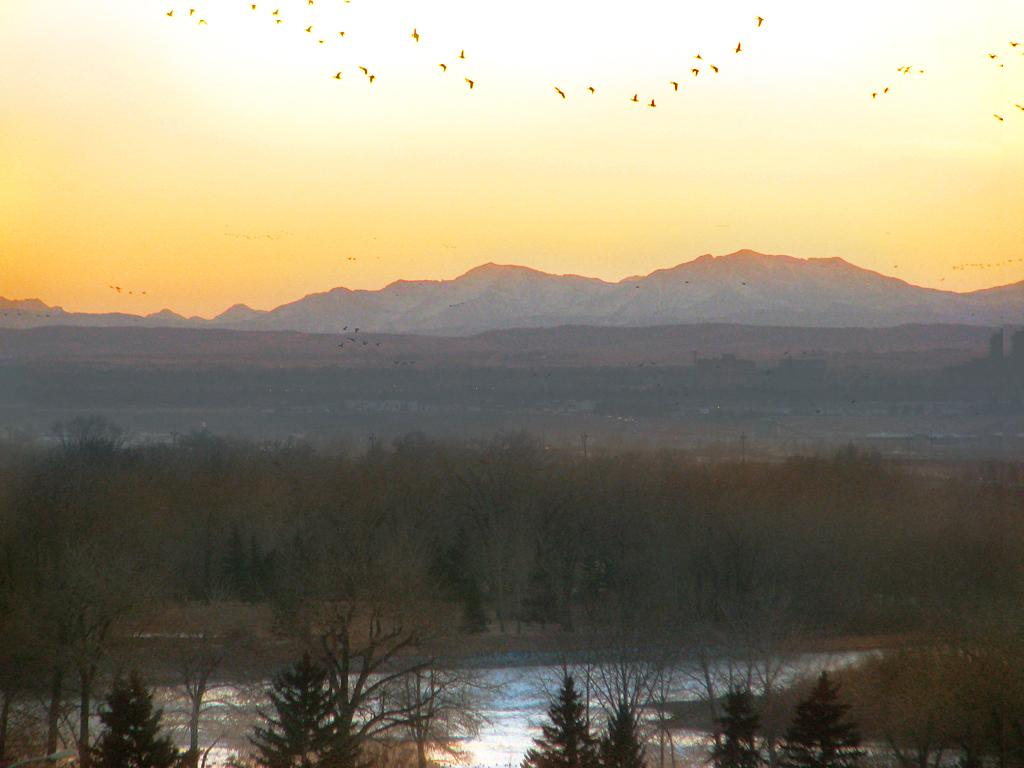What type of vegetation can be seen in the image? There are many trees in the image. What is happening in the sky in the image? Birds are flying in the sky in the image. What geographical feature is visible in the image? There is a mountain visible in the image. What is the weather like in the image? Snow is present in the image, indicating a cold or snowy environment. What is the color of the sky in the image? The sky has a pale orange color in the image. What type of metal is visible on the moon in the image? There is no moon visible in the image, and therefore no metal can be observed. What shape is the ice cream taking in the image? There is no ice cream present in the image, so its shape cannot be determined. 